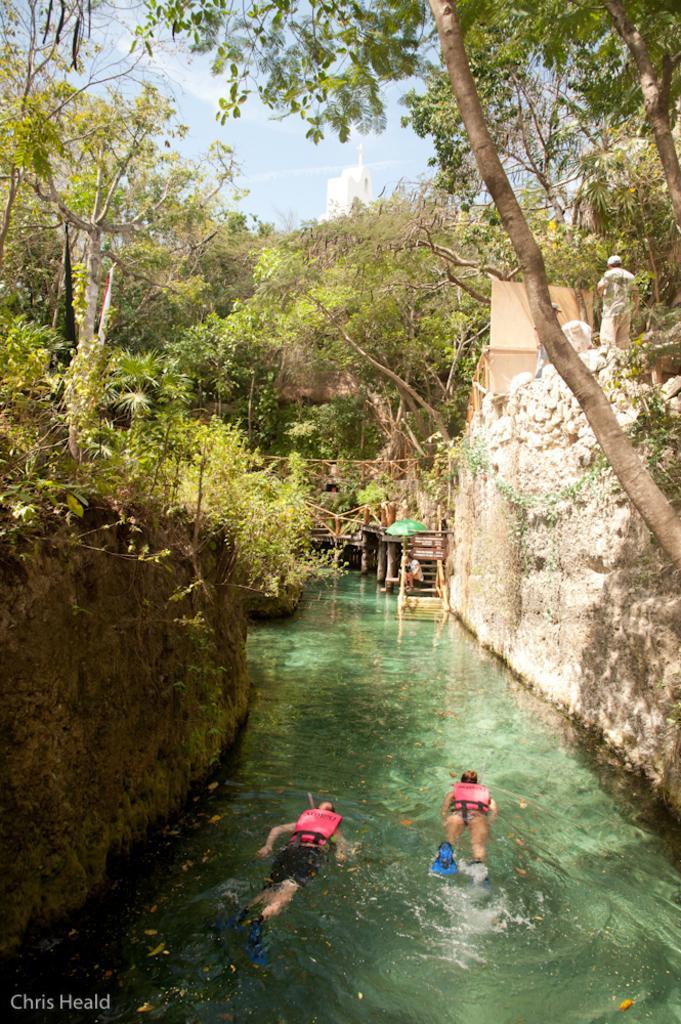Could you give a brief overview of what you see in this image? At the bottom there are two persons swimming in the water. On the right and left side of the image I can see the walls. In the background there are many trees and there are stairs. At the top of the image I can see the sky. In the background there is a building. 